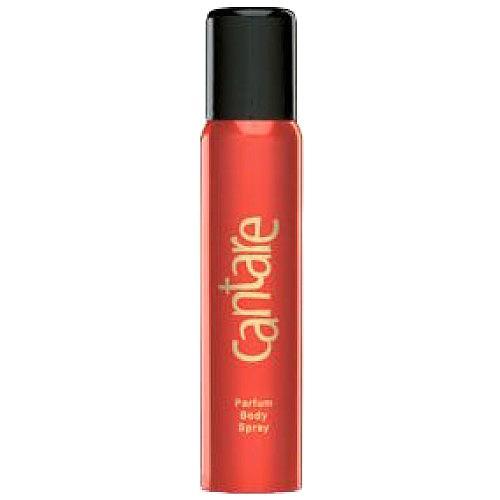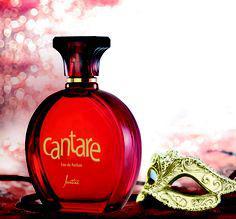The first image is the image on the left, the second image is the image on the right. For the images shown, is this caption "there is at least one perfume bottle with a clear cap" true? Answer yes or no. No. The first image is the image on the left, the second image is the image on the right. Considering the images on both sides, is "The right image contains a slender perfume container that is predominately red." valid? Answer yes or no. No. 